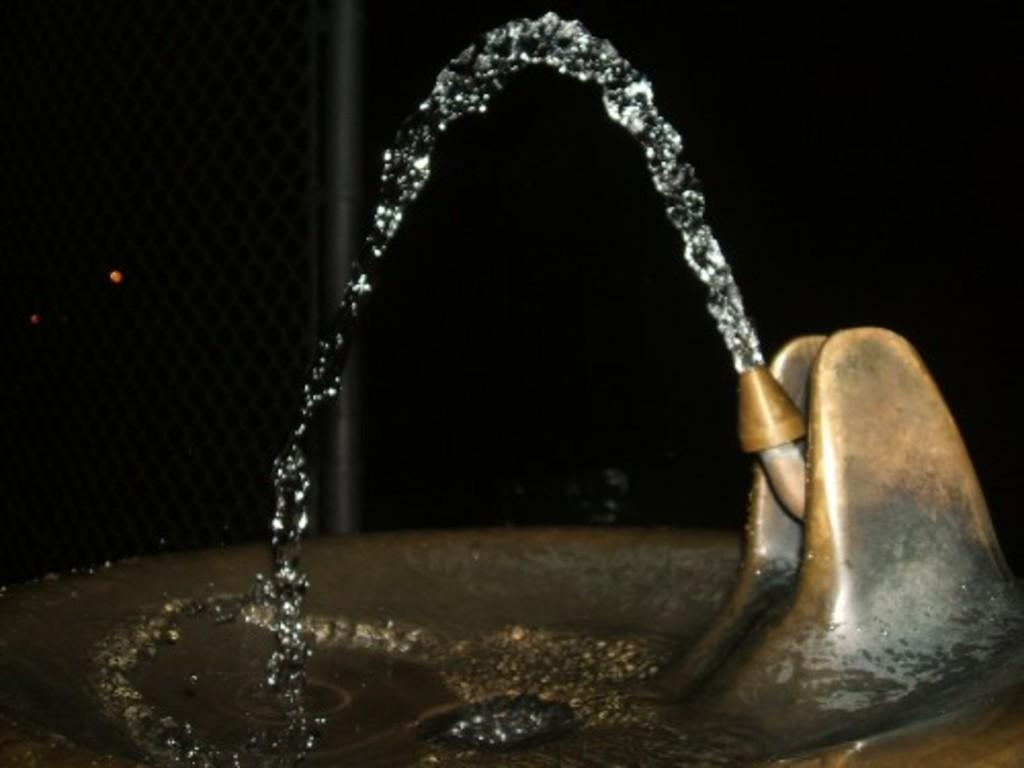What can be found in the image that is used for washing or cleaning? There is a sink with a tap in the image. What is present in the sink? Water is visible in the sink. What other object can be seen in the image? There is a mesh with a rod in the image. What degree of temperature is the water in the sink? The provided facts do not mention the temperature of the water in the sink, so it cannot be determined from the image. 